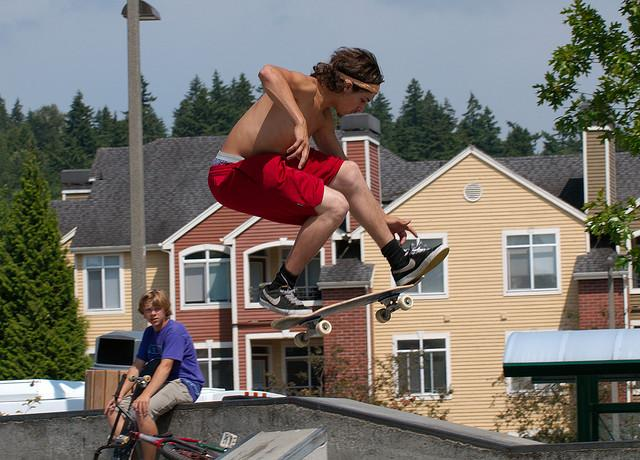What muscle do skater jumps Work?

Choices:
A) shoulder
B) hand
C) elbow
D) rump rump 